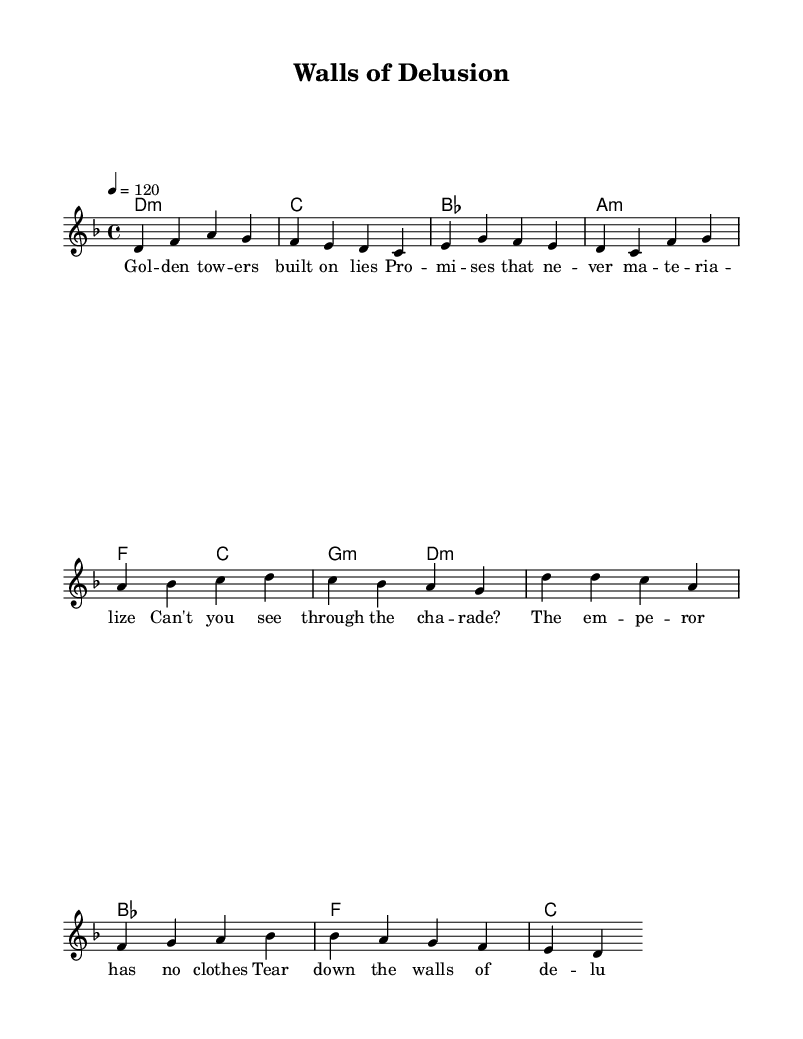What is the key signature of this music? The key signature is identified by the markings at the beginning of the staff. In this case, it's D minor, which has one flat (B flat).
Answer: D minor What is the time signature of this music? The time signature appears at the beginning of the staff, indicating how many beats are in each measure. Here, it's 4/4, meaning four beats per measure.
Answer: 4/4 What is the tempo marking in this music? The tempo marking is found above the staff, indicating the speed of the piece. It is shown as 120 beats per minute, which is a standard tempo for pop songs.
Answer: 120 How many measures are in the verse section? By counting the measures from the first note of the verse to the last note, we see there are 8 distinct measures present.
Answer: 8 What is the first lyric of the chorus? The lyrics are attached to the melody notes. The first lyric under the chorus melody starts with "Can't".
Answer: Can't How many unique chords are used in the verse? The chords used in the verse are one of each type without repetition. Counting from the chord chart, we find four unique chords: D minor, C, B flat, and A minor.
Answer: 4 What theme do these lyrics suggest? By analyzing the lyrics, we see that they discuss themes of deception and illusion, as indicated by the phrases about lies and delusion.
Answer: Deception 